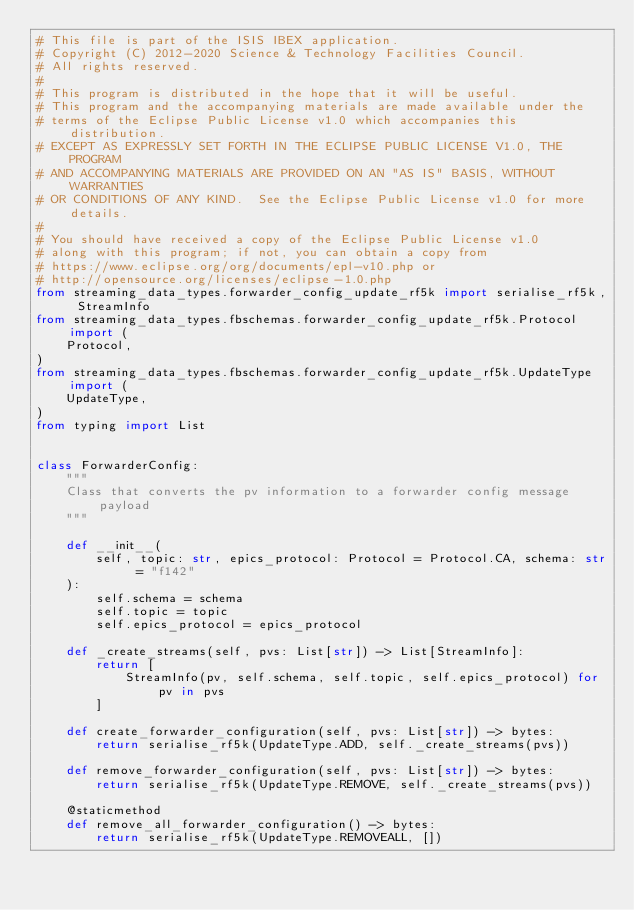<code> <loc_0><loc_0><loc_500><loc_500><_Python_># This file is part of the ISIS IBEX application.
# Copyright (C) 2012-2020 Science & Technology Facilities Council.
# All rights reserved.
#
# This program is distributed in the hope that it will be useful.
# This program and the accompanying materials are made available under the
# terms of the Eclipse Public License v1.0 which accompanies this distribution.
# EXCEPT AS EXPRESSLY SET FORTH IN THE ECLIPSE PUBLIC LICENSE V1.0, THE PROGRAM
# AND ACCOMPANYING MATERIALS ARE PROVIDED ON AN "AS IS" BASIS, WITHOUT WARRANTIES
# OR CONDITIONS OF ANY KIND.  See the Eclipse Public License v1.0 for more details.
#
# You should have received a copy of the Eclipse Public License v1.0
# along with this program; if not, you can obtain a copy from
# https://www.eclipse.org/org/documents/epl-v10.php or
# http://opensource.org/licenses/eclipse-1.0.php
from streaming_data_types.forwarder_config_update_rf5k import serialise_rf5k, StreamInfo
from streaming_data_types.fbschemas.forwarder_config_update_rf5k.Protocol import (
    Protocol,
)
from streaming_data_types.fbschemas.forwarder_config_update_rf5k.UpdateType import (
    UpdateType,
)
from typing import List


class ForwarderConfig:
    """
    Class that converts the pv information to a forwarder config message payload
    """

    def __init__(
        self, topic: str, epics_protocol: Protocol = Protocol.CA, schema: str = "f142"
    ):
        self.schema = schema
        self.topic = topic
        self.epics_protocol = epics_protocol

    def _create_streams(self, pvs: List[str]) -> List[StreamInfo]:
        return [
            StreamInfo(pv, self.schema, self.topic, self.epics_protocol) for pv in pvs
        ]

    def create_forwarder_configuration(self, pvs: List[str]) -> bytes:
        return serialise_rf5k(UpdateType.ADD, self._create_streams(pvs))

    def remove_forwarder_configuration(self, pvs: List[str]) -> bytes:
        return serialise_rf5k(UpdateType.REMOVE, self._create_streams(pvs))

    @staticmethod
    def remove_all_forwarder_configuration() -> bytes:
        return serialise_rf5k(UpdateType.REMOVEALL, [])
</code> 